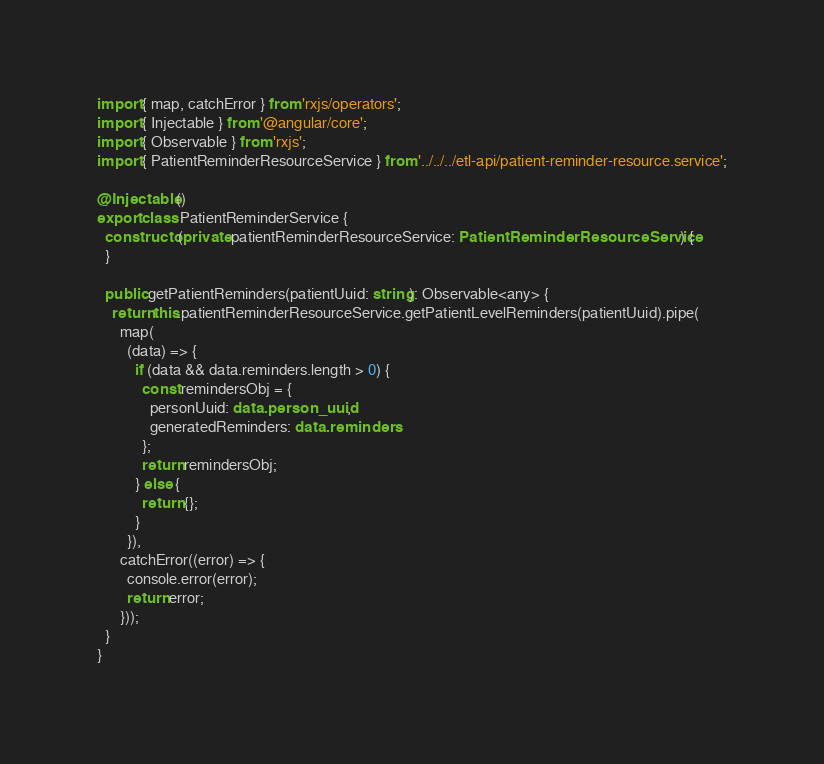Convert code to text. <code><loc_0><loc_0><loc_500><loc_500><_TypeScript_>
import { map, catchError } from 'rxjs/operators';
import { Injectable } from '@angular/core';
import { Observable } from 'rxjs';
import { PatientReminderResourceService } from '../../../etl-api/patient-reminder-resource.service';

@Injectable()
export class PatientReminderService {
  constructor(private patientReminderResourceService: PatientReminderResourceService) {
  }

  public getPatientReminders(patientUuid: string): Observable<any> {
    return this.patientReminderResourceService.getPatientLevelReminders(patientUuid).pipe(
      map(
        (data) => {
          if (data && data.reminders.length > 0) {
            const remindersObj = {
              personUuid: data.person_uuid,
              generatedReminders: data.reminders
            };
            return remindersObj;
          } else {
            return {};
          }
        }),
      catchError((error) => {
        console.error(error);
        return error;
      }));
  }
}
</code> 